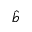<formula> <loc_0><loc_0><loc_500><loc_500>\hat { b }</formula> 